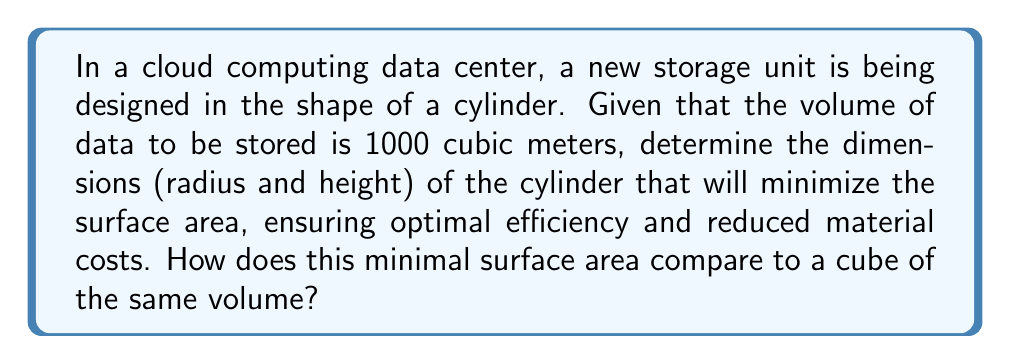Could you help me with this problem? Let's approach this step-by-step:

1) For a cylinder with radius $r$ and height $h$, we have:
   Volume: $V = \pi r^2 h$
   Surface Area: $A = 2\pi r^2 + 2\pi rh$

2) We're given that $V = 1000$ m³, so:
   $1000 = \pi r^2 h$

3) Solve for $h$:
   $h = \frac{1000}{\pi r^2}$

4) Substitute this into the surface area formula:
   $A = 2\pi r^2 + 2\pi r(\frac{1000}{\pi r^2})$
   $A = 2\pi r^2 + \frac{2000}{r}$

5) To find the minimum, differentiate $A$ with respect to $r$ and set to zero:
   $\frac{dA}{dr} = 4\pi r - \frac{2000}{r^2} = 0$

6) Solve this equation:
   $4\pi r^3 = 2000$
   $r^3 = \frac{500}{\pi}$
   $r = (\frac{500}{\pi})^{\frac{1}{3}} \approx 5.42$ m

7) Find $h$ using the relation from step 3:
   $h = \frac{1000}{\pi r^2} \approx 10.84$ m

8) Calculate the minimal surface area:
   $A_{min} = 2\pi r^2 + 2\pi rh \approx 554.58$ m²

9) For comparison, a cube of volume 1000 m³ would have side length $10$ m and surface area $600$ m².
Answer: Cylinder dimensions: $r \approx 5.42$ m, $h \approx 10.84$ m. Minimal surface area: $554.58$ m². Compared to cube: $45.42$ m² less. 